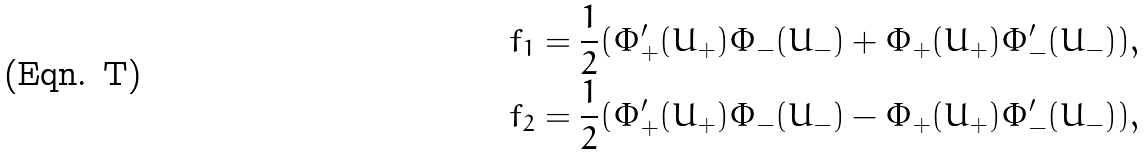Convert formula to latex. <formula><loc_0><loc_0><loc_500><loc_500>f _ { 1 } & = \frac { 1 } { 2 } ( \Phi _ { + } ^ { \prime } ( U _ { + } ) \Phi _ { - } ( U _ { - } ) + \Phi _ { + } ( U _ { + } ) \Phi _ { - } ^ { \prime } ( U _ { - } ) ) , \\ f _ { 2 } & = \frac { 1 } { 2 } ( \Phi _ { + } ^ { \prime } ( U _ { + } ) \Phi _ { - } ( U _ { - } ) - \Phi _ { + } ( U _ { + } ) \Phi _ { - } ^ { \prime } ( U _ { - } ) ) ,</formula> 